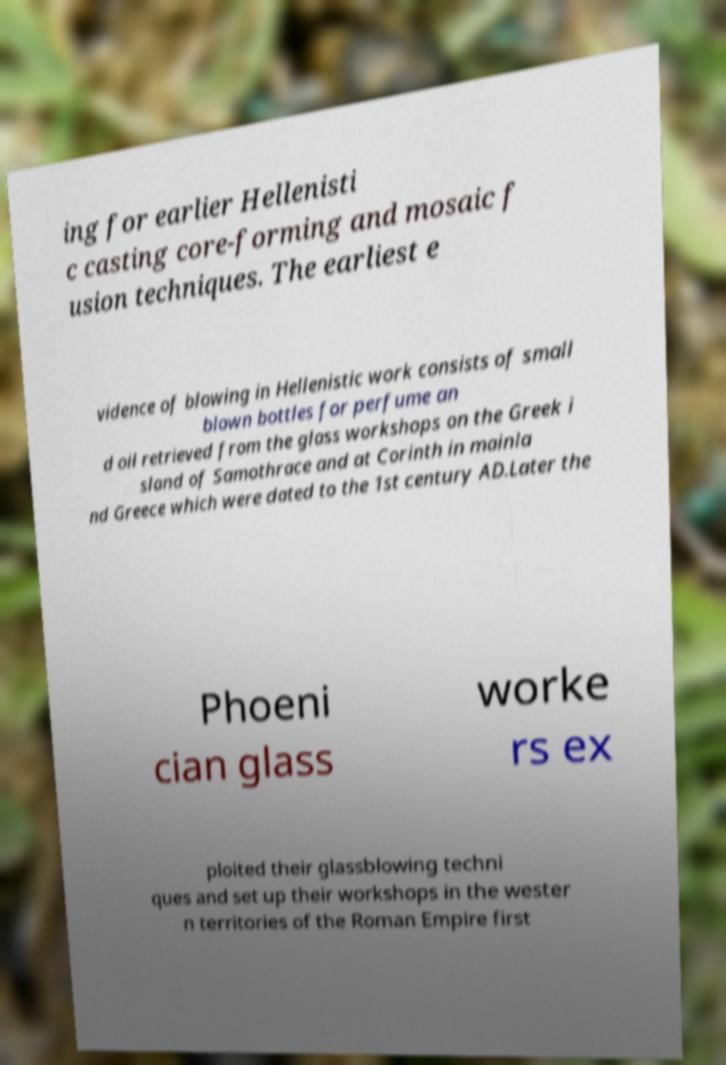Please read and relay the text visible in this image. What does it say? ing for earlier Hellenisti c casting core-forming and mosaic f usion techniques. The earliest e vidence of blowing in Hellenistic work consists of small blown bottles for perfume an d oil retrieved from the glass workshops on the Greek i sland of Samothrace and at Corinth in mainla nd Greece which were dated to the 1st century AD.Later the Phoeni cian glass worke rs ex ploited their glassblowing techni ques and set up their workshops in the wester n territories of the Roman Empire first 